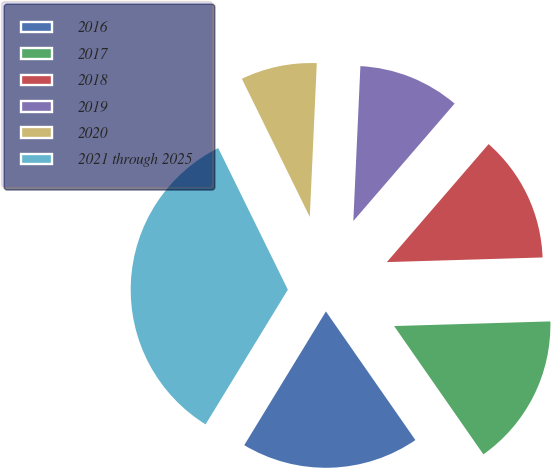Convert chart. <chart><loc_0><loc_0><loc_500><loc_500><pie_chart><fcel>2016<fcel>2017<fcel>2018<fcel>2019<fcel>2020<fcel>2021 through 2025<nl><fcel>18.4%<fcel>15.8%<fcel>13.2%<fcel>10.6%<fcel>8.0%<fcel>34.0%<nl></chart> 